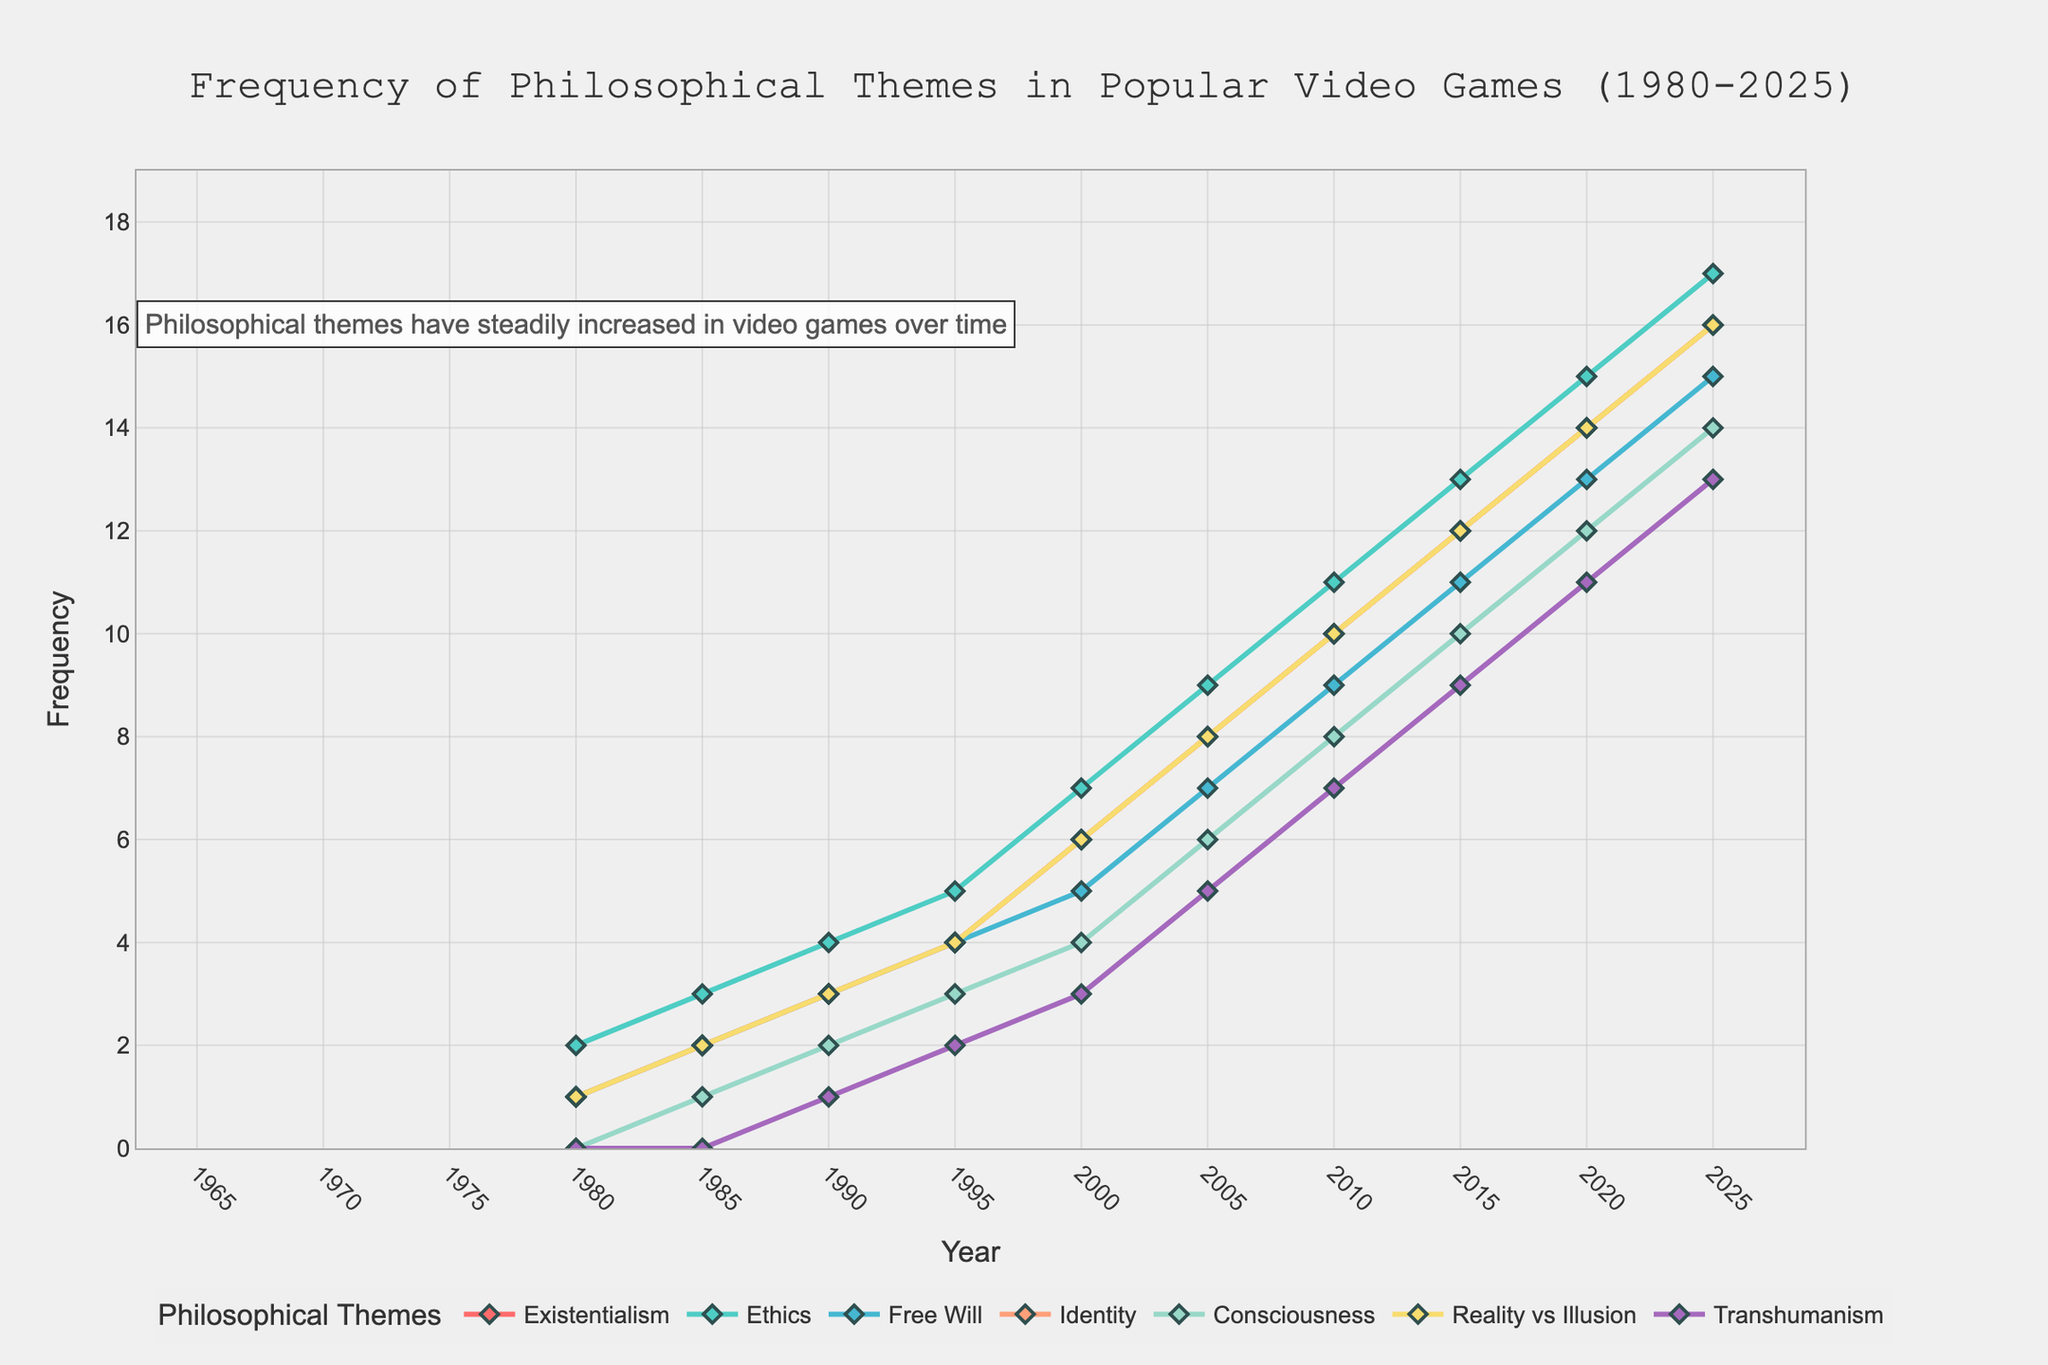What's the frequency trend of "Reality vs Illusion" from 1980 to 2025? To identify the trend, observe the line and markers that represent "Reality vs Illusion". The frequency starts at 1 in 1980 and consistently rises over the years, reaching 16 by 2025.
Answer: Increasing Which philosophical theme has the highest frequency in 2020? Look at the endpoints of all the lines for the year 2020. The theme with the highest marker is "Ethics" with a value of 15.
Answer: Ethics How does the frequency of "Existentialism" in 2000 compare to that of "Consciousness" in 2015? Check the respective markers for "Existentialism" in 2000 (6) and "Consciousness" in 2015 (10). "Consciousness" has a higher frequency by 4.
Answer: Consciousness is higher by 4 What is the sum of frequencies of "Identity" and "Transhumanism" in 2015? Identify the frequency of "Identity" in 2015 (12) and "Transhumanism" in 2015 (9). Adding these two gives 12 + 9 = 21.
Answer: 21 Which theme shows the least growth from 1980 to 2025? Calculate the difference between frequencies in 2025 and 1980 for each theme. Compare these values. "Transhumanism" grows from 0 to 13, reflecting a growth of 13, which is the least compared to others.
Answer: Transhumanism What's the average frequency of "Free Will" over the years presented? Sum the frequencies of "Free Will" for all given years (1+2+3+4+5+7+9+11+13+15) = 70. There are 10 years, hence the average is 70/10 = 7.
Answer: 7 How does the frequency growth of "Ethics" over 25 years (2000 to 2025) compare to that of "Existentialism" over the same period? For "Ethics", the frequency grows from 7 to 17, giving an increase of 10. For "Existentialism", it increases from 6 to 16, also an increase of 10. Therefore, both grow by the same amount.
Answer: Equal By how much did the frequency of "Transhumanism" increase from 2000 to 2020? Locate the markers for "Transhumanism" in 2000 (3) and 2020 (11). The increase is 11 - 3 = 8.
Answer: 8 